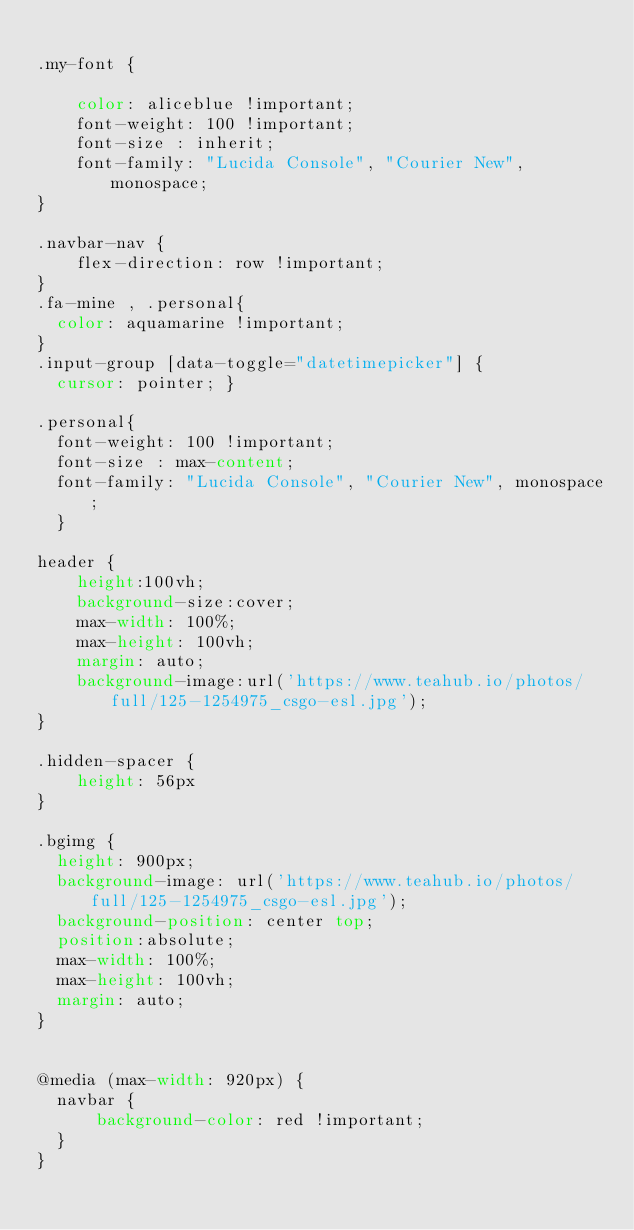<code> <loc_0><loc_0><loc_500><loc_500><_CSS_>
.my-font {
   
    color: aliceblue !important;
    font-weight: 100 !important;
    font-size : inherit;
    font-family: "Lucida Console", "Courier New", monospace;
}

.navbar-nav {
    flex-direction: row !important;
}
.fa-mine , .personal{
  color: aquamarine !important;
}
.input-group [data-toggle="datetimepicker"] {
  cursor: pointer; }

.personal{
  font-weight: 100 !important;
  font-size : max-content;
  font-family: "Lucida Console", "Courier New", monospace;
  }
  
header {
    height:100vh;
    background-size:cover;
    max-width: 100%;
    max-height: 100vh;
    margin: auto;
    background-image:url('https://www.teahub.io/photos/full/125-1254975_csgo-esl.jpg');
}

.hidden-spacer {
    height: 56px
}

.bgimg {
  height: 900px;
  background-image: url('https://www.teahub.io/photos/full/125-1254975_csgo-esl.jpg');
  background-position: center top;
  position:absolute;
  max-width: 100%;
  max-height: 100vh;
  margin: auto;
}


@media (max-width: 920px) {
  navbar {
      background-color: red !important;
  }
}



</code> 